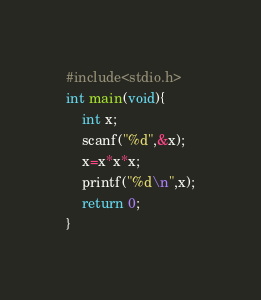<code> <loc_0><loc_0><loc_500><loc_500><_C_>#include<stdio.h>
int main(void){
    int x;
    scanf("%d",&x);
    x=x*x*x;
    printf("%d\n",x);
    return 0;
}</code> 